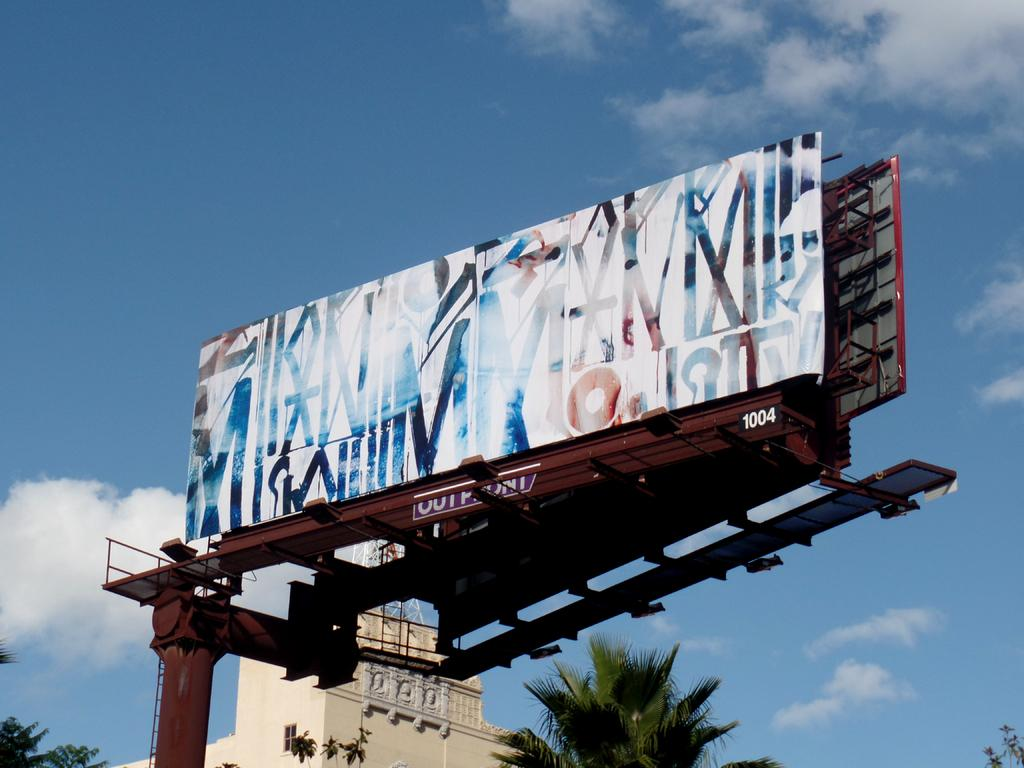<image>
Write a terse but informative summary of the picture. a large billboard with random letters on it is number 1004 